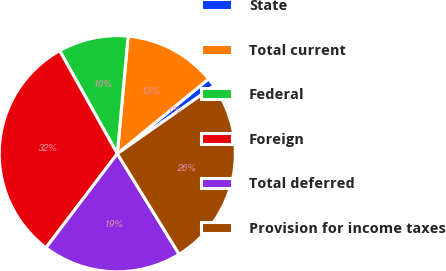Convert chart to OTSL. <chart><loc_0><loc_0><loc_500><loc_500><pie_chart><fcel>State<fcel>Total current<fcel>Federal<fcel>Foreign<fcel>Total deferred<fcel>Provision for income taxes<nl><fcel>1.19%<fcel>12.62%<fcel>9.58%<fcel>31.55%<fcel>19.1%<fcel>25.95%<nl></chart> 